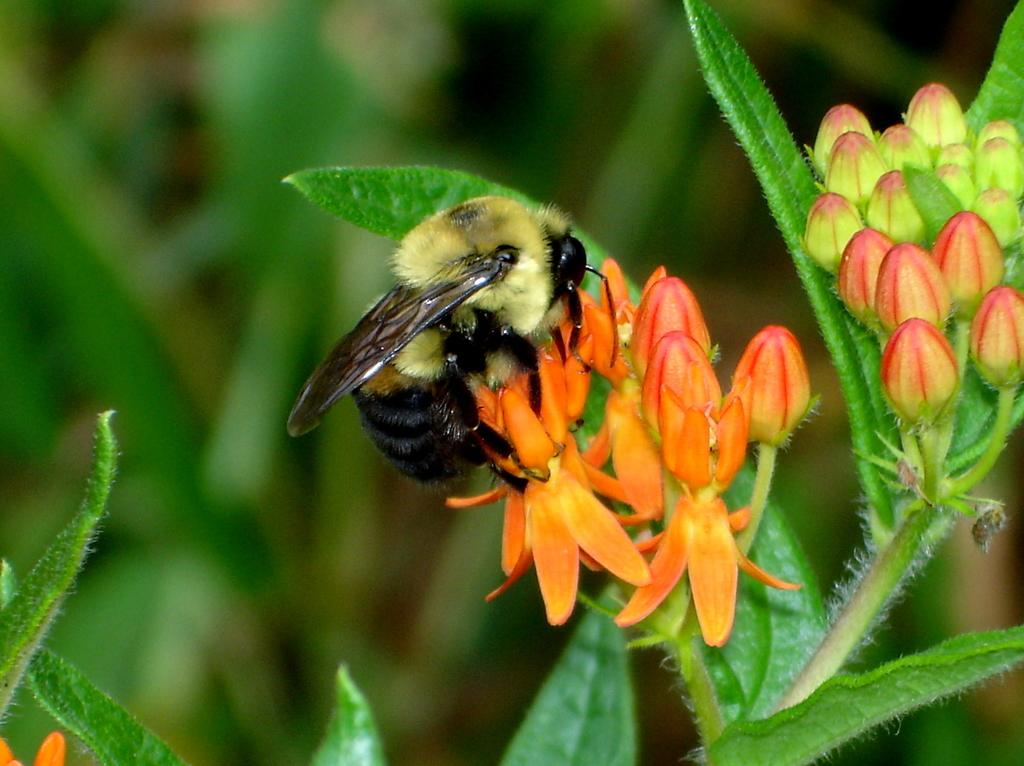What is the main subject of the image? There is a honey bee in the image. What is the honey bee doing in the image? The honey bee is sitting on a flower. What can be seen at the bottom of the image? There is a plant at the bottom of the image. How would you describe the background of the image? The background of the image is blurred. How many passengers are visible in the image? There are no passengers present in the image, as it features a honey bee sitting on a flower. 